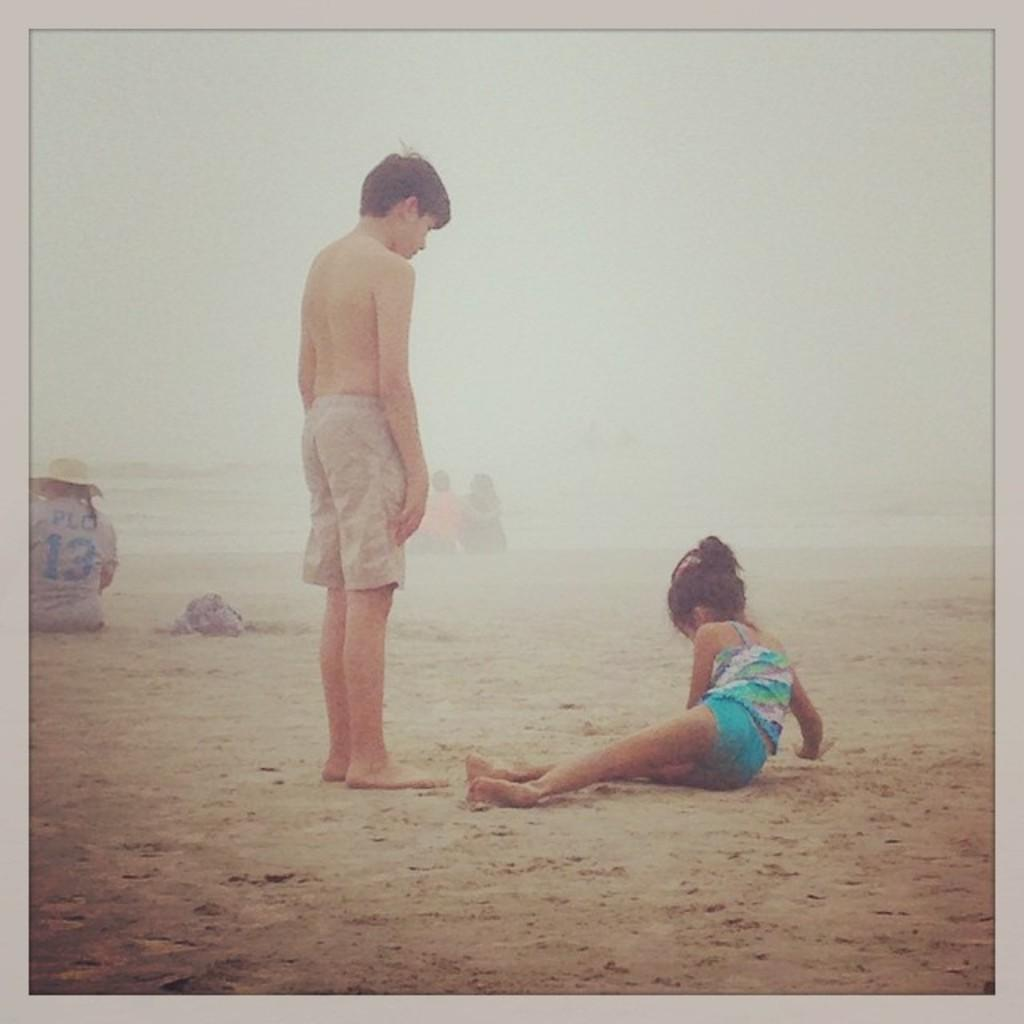How many children are in the image? There are two children in the image. What is the surface the children are standing on? The children are on the sand. What color is the background of the image? The background of the image is white. Can you hear the children laughing in the image? The image is a still picture, so there is no sound or audio to indicate if the children are laughing or not. 